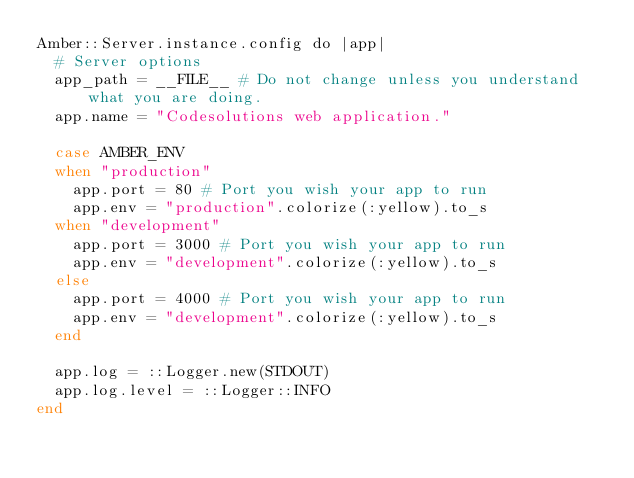Convert code to text. <code><loc_0><loc_0><loc_500><loc_500><_Crystal_>Amber::Server.instance.config do |app|
  # Server options
  app_path = __FILE__ # Do not change unless you understand what you are doing.
  app.name = "Codesolutions web application."

  case AMBER_ENV
  when "production"
    app.port = 80 # Port you wish your app to run
    app.env = "production".colorize(:yellow).to_s
  when "development"
    app.port = 3000 # Port you wish your app to run
    app.env = "development".colorize(:yellow).to_s
  else
    app.port = 4000 # Port you wish your app to run
    app.env = "development".colorize(:yellow).to_s
  end

  app.log = ::Logger.new(STDOUT)
  app.log.level = ::Logger::INFO
end
</code> 